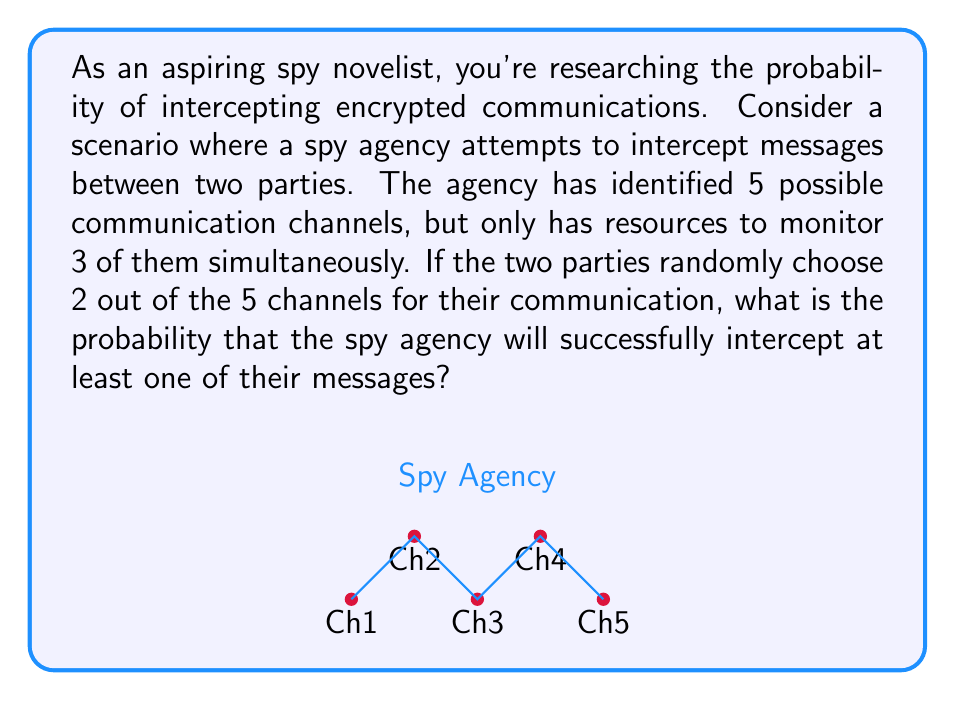Help me with this question. Let's approach this step-by-step:

1) First, we need to calculate the total number of ways the spy agency can choose 3 channels out of 5. This is given by the combination formula:

   $$\binom{5}{3} = \frac{5!}{3!(5-3)!} = \frac{5 \cdot 4 \cdot 3}{3 \cdot 2 \cdot 1} = 10$$

2) Now, we need to calculate the number of ways the two parties can choose 2 channels out of 5:

   $$\binom{5}{2} = \frac{5!}{2!(5-2)!} = \frac{5 \cdot 4}{2 \cdot 1} = 10$$

3) For the spy agency to intercept at least one message, they need to monitor at least one of the two channels chosen by the parties. It's easier to calculate the probability of the complement event - the probability that the agency fails to monitor both channels.

4) The agency fails if they choose all 3 of their channels from the 3 channels not used by the parties. The number of ways to do this is:

   $$\binom{3}{3} = 1$$

5) Therefore, the probability of failure is:

   $$P(\text{failure}) = \frac{1}{10} = 0.1$$

6) The probability of success is the complement of this:

   $$P(\text{success}) = 1 - P(\text{failure}) = 1 - 0.1 = 0.9$$

Thus, the probability of successfully intercepting at least one message is 0.9 or 90%.
Answer: $0.9$ or $90\%$ 